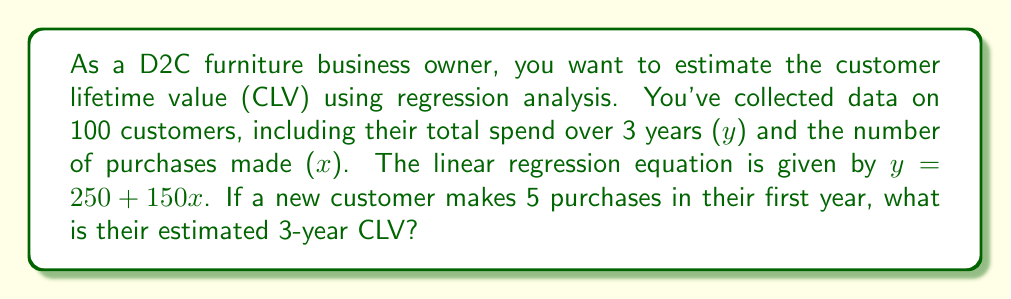Show me your answer to this math problem. To solve this problem, we'll follow these steps:

1. Understand the given information:
   - Linear regression equation: $y = 250 + 150x$
   - $y$ represents the total spend over 3 years (CLV)
   - $x$ represents the number of purchases made

2. Identify the value for $x$:
   - The new customer makes 5 purchases in their first year
   - Therefore, $x = 5$

3. Substitute $x = 5$ into the regression equation:
   $y = 250 + 150(5)$

4. Calculate the estimated CLV:
   $y = 250 + 750$
   $y = 1000$

The estimated 3-year CLV for the new customer who makes 5 purchases in their first year is $1000.

This regression analysis helps predict future customer value based on their initial purchasing behavior, allowing you to make informed decisions about customer acquisition and retention strategies for your D2C furniture business.
Answer: $1000 